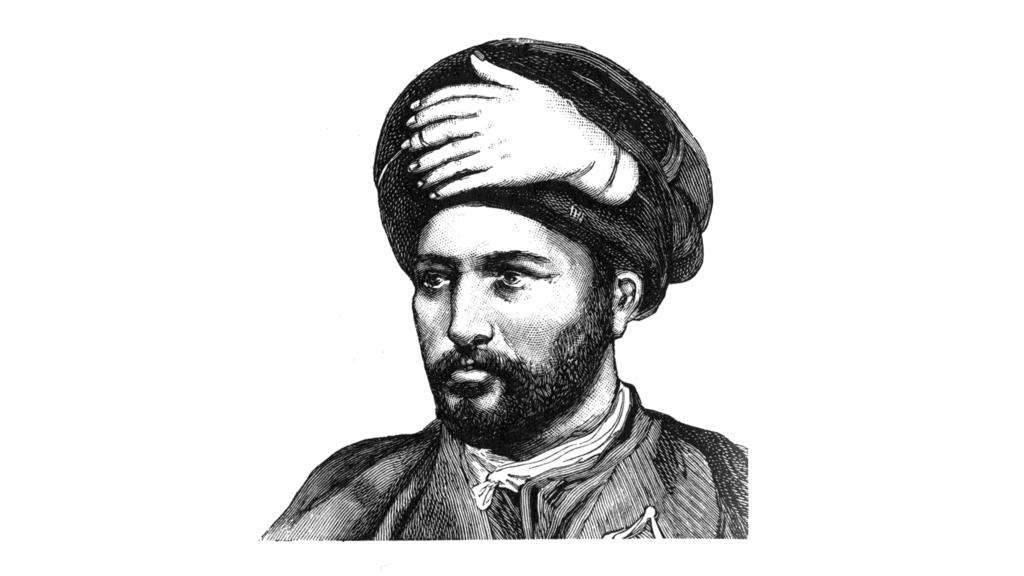What is the main subject of the image? The main subject of the image is a picture of a man. What can be seen on the man's head in the image? The man is wearing a turban on his head. What type of stick is the man holding in the image? There is no stick present in the image; the man is only wearing a turban on his head. 